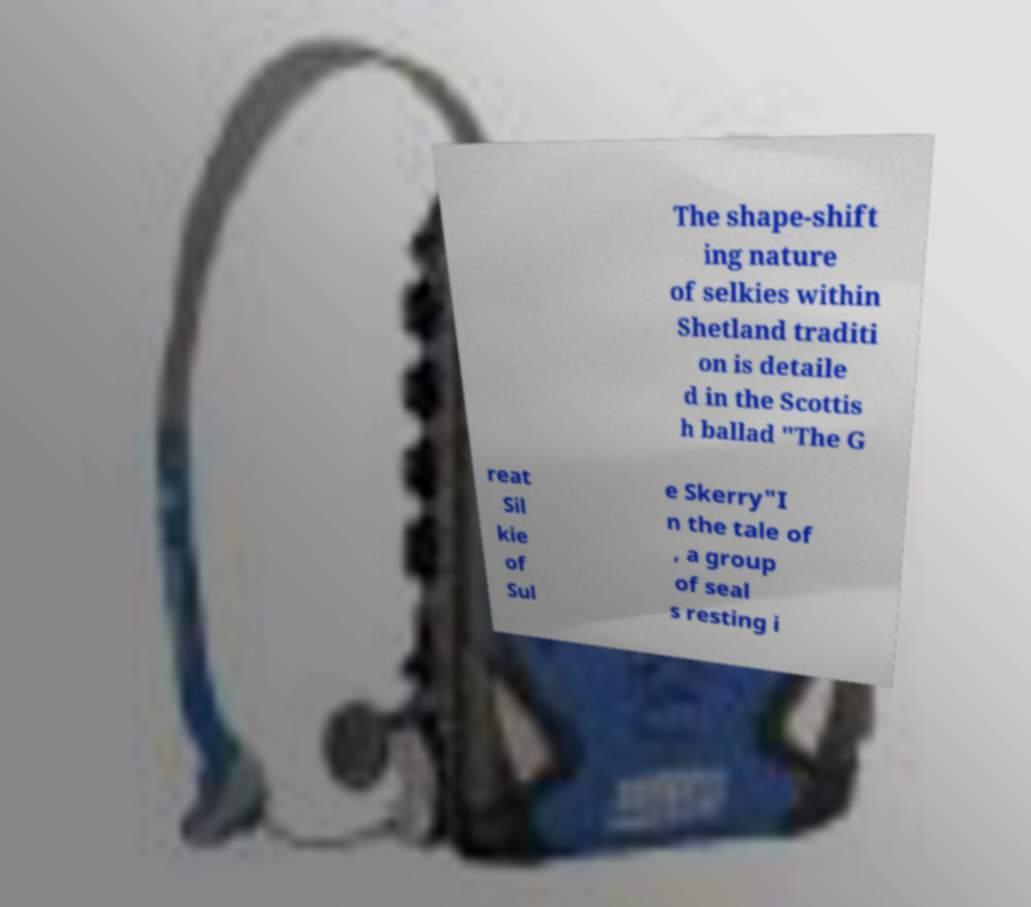For documentation purposes, I need the text within this image transcribed. Could you provide that? The shape-shift ing nature of selkies within Shetland traditi on is detaile d in the Scottis h ballad "The G reat Sil kie of Sul e Skerry"I n the tale of , a group of seal s resting i 